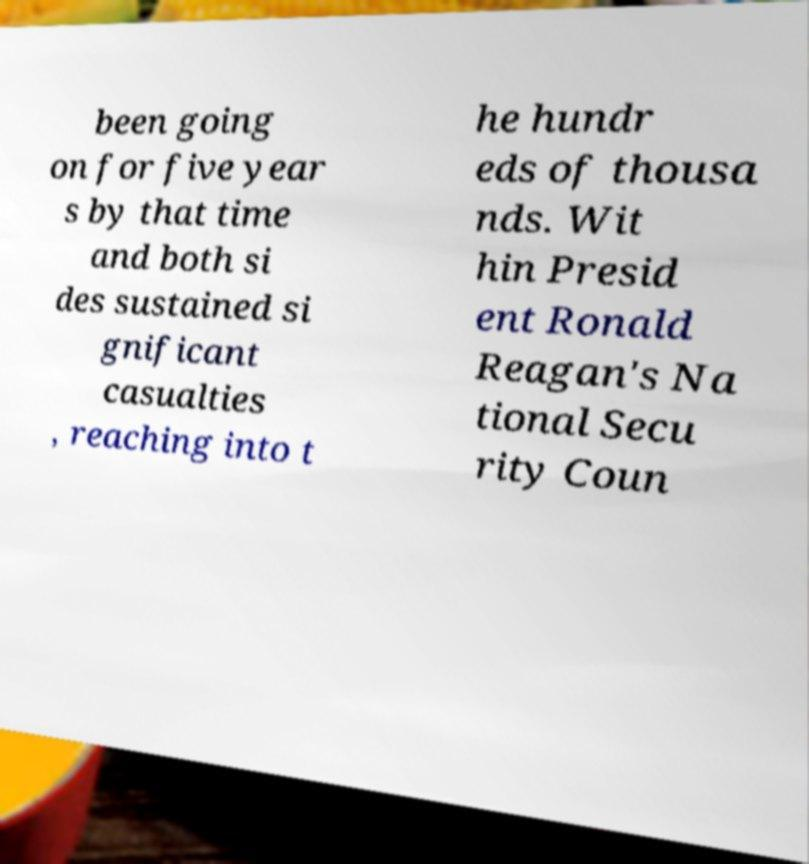There's text embedded in this image that I need extracted. Can you transcribe it verbatim? been going on for five year s by that time and both si des sustained si gnificant casualties , reaching into t he hundr eds of thousa nds. Wit hin Presid ent Ronald Reagan's Na tional Secu rity Coun 